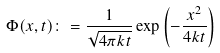<formula> <loc_0><loc_0><loc_500><loc_500>\Phi ( x , t ) \colon = { \frac { 1 } { \sqrt { 4 \pi k t } } } \exp \left ( - { \frac { x ^ { 2 } } { 4 k t } } \right )</formula> 